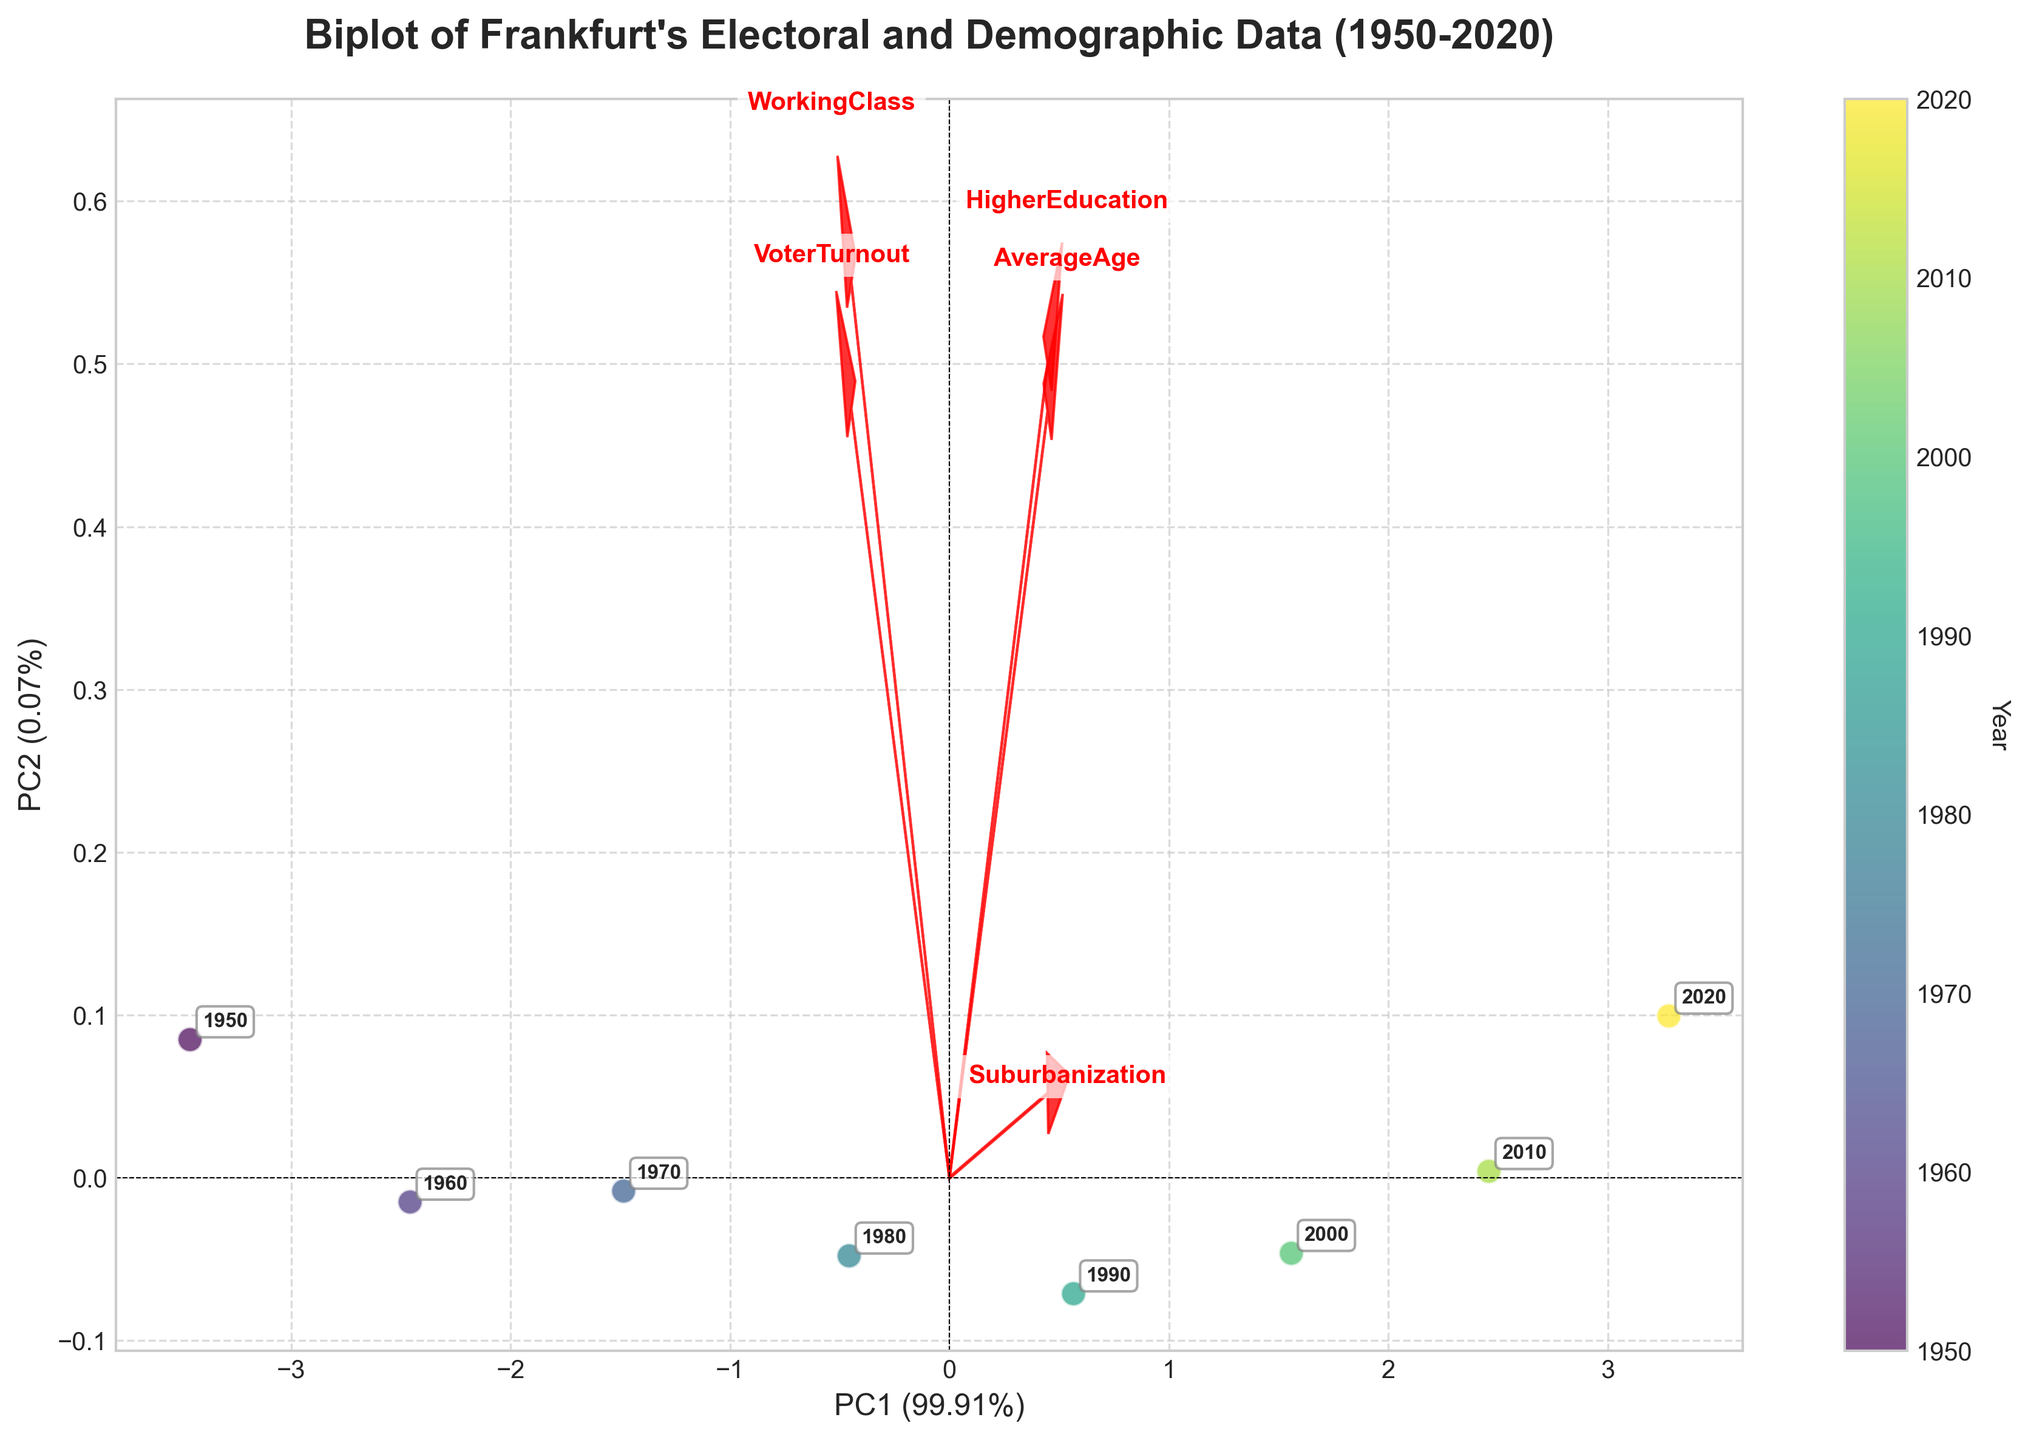What is the title of the figure? The title is usually the text at the top of the figure, providing a summary of the visual representation. In this case, it describes the biplot's content and scope.
Answer: Biplot of Frankfurt's Electoral and Demographic Data (1950-2020) Which year is represented by the point with the highest value on PC1? The highest value on PC1 can be found by looking at the rightmost data point on the x-axis of the biplot, then checking its annotation.
Answer: 2020 How many principal components are represented in this biplot? A biplot typically shows two principal components as indicated by the two axes labeled (PC1 and PC2) in the figure.
Answer: 2 What does the length and direction of the arrow for 'HigherEducation' indicate? The length of the arrow shows the strength of the correlation between the variable 'HigherEducation' and the principal components, while the direction indicates how the variable is weighted on those components.
Answer: Strong, positive correlation with PC1 What trend is observed in voter turnout across the years? By looking at how the data points for 'VoterTurnout' align on the plot, you can interpret the trend. Points cluster tighter and lower over the years, indicating a decrease.
Answer: Decreasing trend Compare the influence of 'AverageAge' and 'Suburbanization' on the principal components. Which has a greater influence and why? This can be determined by comparing the lengths of the vectors for 'AverageAge' and 'Suburbanization' on the biplot. The longer the vector, the more influence it has.
Answer: Suburbanization; longer vector What does the spread of points along PC2 tell us about the variability in the data? A wider spread along the vertical axis (PC2) indicates greater variability among the data points in respect to the second principal component.
Answer: High variability Based on the biplot, what period experienced the largest demographic shift in the variables considered? By comparing the distance between points across the biplot, the period with the largest gaps between years can be identified as having the most significant changes. The gap between 1970 and 1980 seems particularly large.
Answer: Between 1970 and 1980 How is the 'WorkingClass' variable represented in the biplot in relation to 'HigherEducation'? The direction of vectors of 'WorkingClass' and 'HigherEducation' relative to each other can indicate their relationship. Opposite directions indicate a negative correlation.
Answer: Negatively correlated 